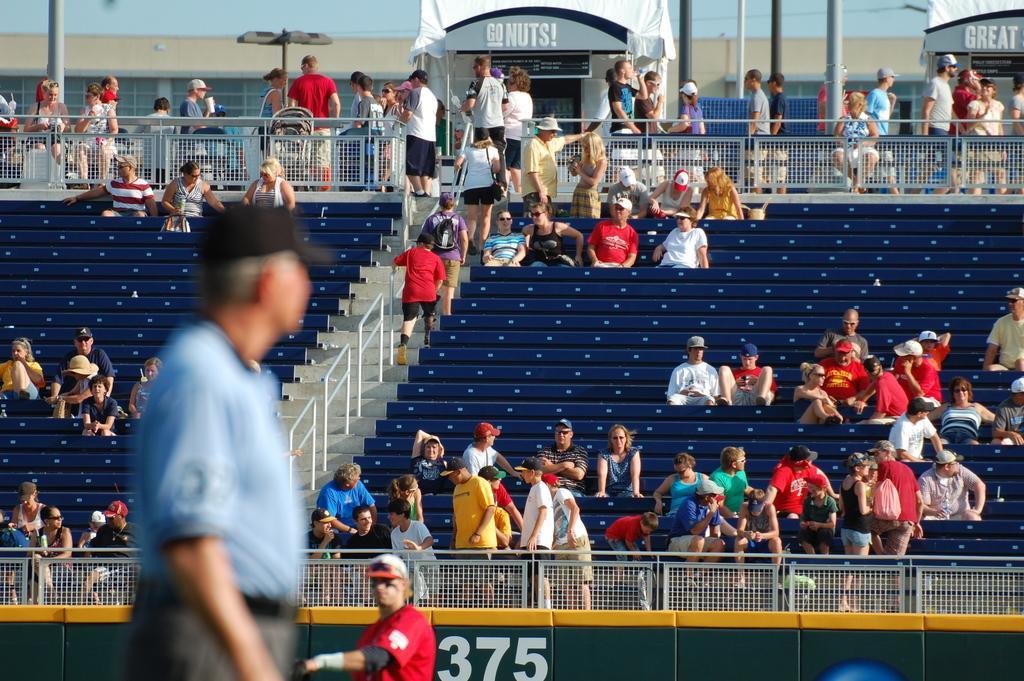Could you give a brief overview of what you see in this image? In this image we can see many people are sitting in the stadium. There are few people standing in the stadium. There are many poles in the image. There are lights in the image. 